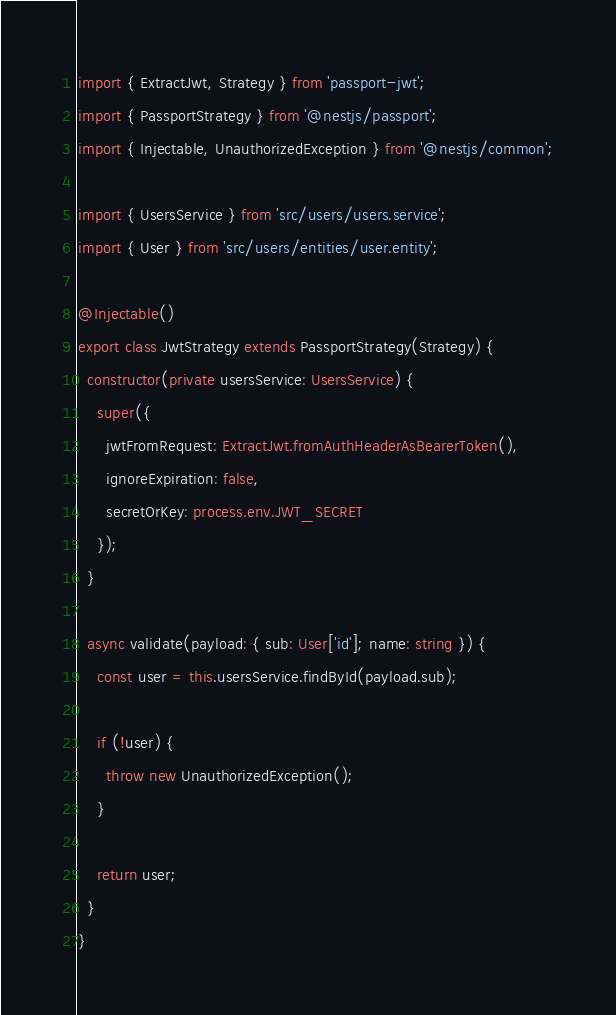<code> <loc_0><loc_0><loc_500><loc_500><_TypeScript_>import { ExtractJwt, Strategy } from 'passport-jwt';
import { PassportStrategy } from '@nestjs/passport';
import { Injectable, UnauthorizedException } from '@nestjs/common';

import { UsersService } from 'src/users/users.service';
import { User } from 'src/users/entities/user.entity';

@Injectable()
export class JwtStrategy extends PassportStrategy(Strategy) {
  constructor(private usersService: UsersService) {
    super({
      jwtFromRequest: ExtractJwt.fromAuthHeaderAsBearerToken(),
      ignoreExpiration: false,
      secretOrKey: process.env.JWT_SECRET
    });
  }

  async validate(payload: { sub: User['id']; name: string }) {
    const user = this.usersService.findById(payload.sub);

    if (!user) {
      throw new UnauthorizedException();
    }

    return user;
  }
}
</code> 